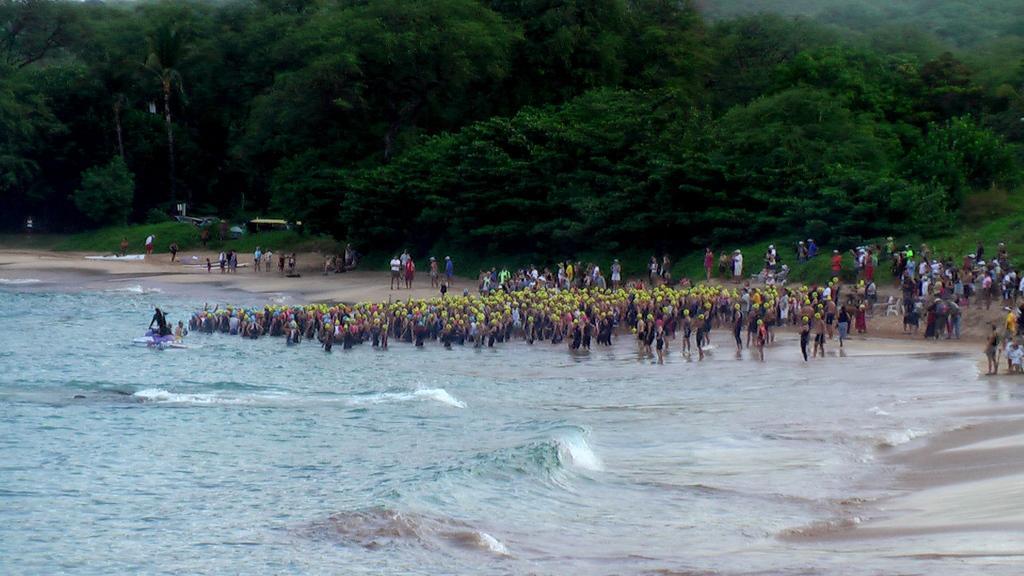Please provide a concise description of this image. In the center of the image we can see a group of people wearing caps are standing in water. To the right side of the image we can see some people standing on the ground. On the left side of the image we can see a person on boat placed in the water. In the background, we can see a group of trees. 